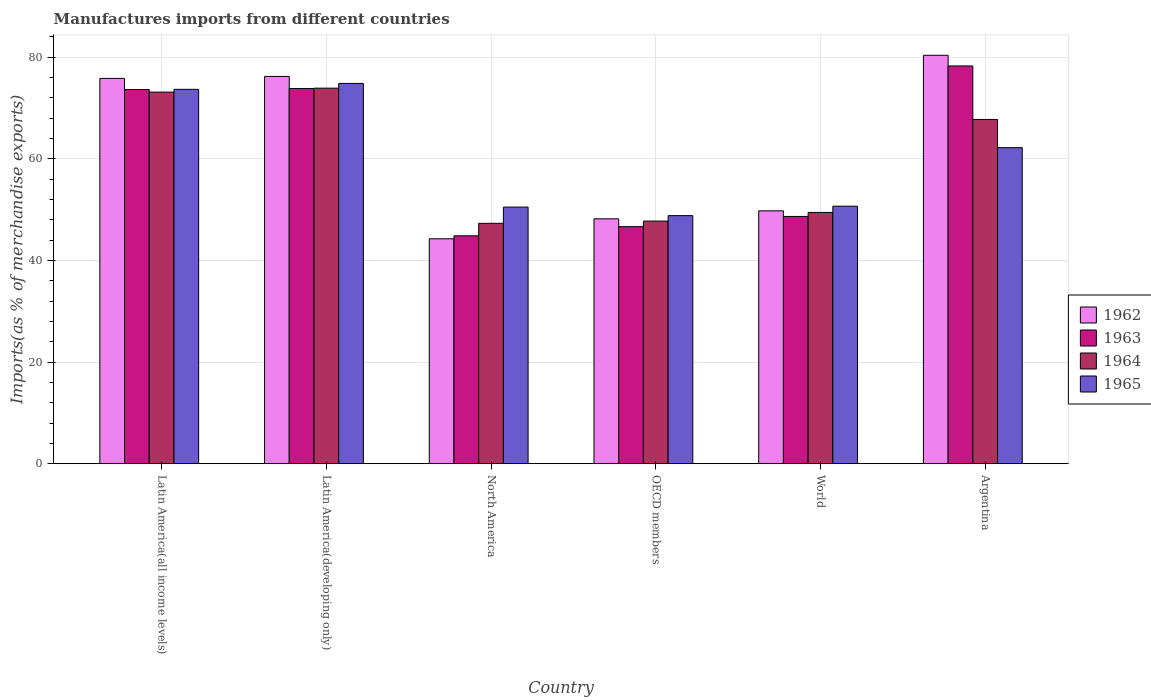How many different coloured bars are there?
Keep it short and to the point. 4. Are the number of bars per tick equal to the number of legend labels?
Make the answer very short. Yes. How many bars are there on the 4th tick from the left?
Give a very brief answer. 4. What is the percentage of imports to different countries in 1963 in OECD members?
Give a very brief answer. 46.65. Across all countries, what is the maximum percentage of imports to different countries in 1963?
Your answer should be very brief. 78.27. Across all countries, what is the minimum percentage of imports to different countries in 1962?
Your response must be concise. 44.26. In which country was the percentage of imports to different countries in 1965 maximum?
Provide a succinct answer. Latin America(developing only). What is the total percentage of imports to different countries in 1963 in the graph?
Your answer should be very brief. 365.9. What is the difference between the percentage of imports to different countries in 1962 in Latin America(all income levels) and that in World?
Ensure brevity in your answer.  26.06. What is the difference between the percentage of imports to different countries in 1965 in North America and the percentage of imports to different countries in 1962 in Latin America(all income levels)?
Offer a terse response. -25.32. What is the average percentage of imports to different countries in 1963 per country?
Provide a succinct answer. 60.98. What is the difference between the percentage of imports to different countries of/in 1965 and percentage of imports to different countries of/in 1963 in North America?
Give a very brief answer. 5.65. What is the ratio of the percentage of imports to different countries in 1963 in OECD members to that in World?
Give a very brief answer. 0.96. What is the difference between the highest and the second highest percentage of imports to different countries in 1965?
Your answer should be compact. -1.16. What is the difference between the highest and the lowest percentage of imports to different countries in 1962?
Offer a terse response. 36.1. Is the sum of the percentage of imports to different countries in 1965 in Argentina and North America greater than the maximum percentage of imports to different countries in 1964 across all countries?
Provide a short and direct response. Yes. What does the 3rd bar from the left in Argentina represents?
Make the answer very short. 1964. Is it the case that in every country, the sum of the percentage of imports to different countries in 1964 and percentage of imports to different countries in 1963 is greater than the percentage of imports to different countries in 1962?
Give a very brief answer. Yes. How many bars are there?
Provide a succinct answer. 24. How many countries are there in the graph?
Offer a terse response. 6. What is the difference between two consecutive major ticks on the Y-axis?
Your answer should be compact. 20. Are the values on the major ticks of Y-axis written in scientific E-notation?
Offer a very short reply. No. Does the graph contain any zero values?
Provide a short and direct response. No. How many legend labels are there?
Your answer should be very brief. 4. How are the legend labels stacked?
Your answer should be very brief. Vertical. What is the title of the graph?
Offer a terse response. Manufactures imports from different countries. What is the label or title of the Y-axis?
Your answer should be compact. Imports(as % of merchandise exports). What is the Imports(as % of merchandise exports) in 1962 in Latin America(all income levels)?
Keep it short and to the point. 75.82. What is the Imports(as % of merchandise exports) in 1963 in Latin America(all income levels)?
Your answer should be compact. 73.64. What is the Imports(as % of merchandise exports) in 1964 in Latin America(all income levels)?
Offer a terse response. 73.13. What is the Imports(as % of merchandise exports) in 1965 in Latin America(all income levels)?
Your response must be concise. 73.67. What is the Imports(as % of merchandise exports) of 1962 in Latin America(developing only)?
Your answer should be very brief. 76.21. What is the Imports(as % of merchandise exports) of 1963 in Latin America(developing only)?
Offer a terse response. 73.84. What is the Imports(as % of merchandise exports) in 1964 in Latin America(developing only)?
Your response must be concise. 73.9. What is the Imports(as % of merchandise exports) in 1965 in Latin America(developing only)?
Your answer should be very brief. 74.83. What is the Imports(as % of merchandise exports) of 1962 in North America?
Your answer should be very brief. 44.26. What is the Imports(as % of merchandise exports) in 1963 in North America?
Ensure brevity in your answer.  44.85. What is the Imports(as % of merchandise exports) in 1964 in North America?
Provide a succinct answer. 47.3. What is the Imports(as % of merchandise exports) of 1965 in North America?
Offer a terse response. 50.5. What is the Imports(as % of merchandise exports) in 1962 in OECD members?
Provide a short and direct response. 48.19. What is the Imports(as % of merchandise exports) of 1963 in OECD members?
Provide a succinct answer. 46.65. What is the Imports(as % of merchandise exports) of 1964 in OECD members?
Your response must be concise. 47.75. What is the Imports(as % of merchandise exports) of 1965 in OECD members?
Provide a short and direct response. 48.82. What is the Imports(as % of merchandise exports) of 1962 in World?
Your answer should be compact. 49.76. What is the Imports(as % of merchandise exports) of 1963 in World?
Provide a succinct answer. 48.66. What is the Imports(as % of merchandise exports) of 1964 in World?
Provide a succinct answer. 49.45. What is the Imports(as % of merchandise exports) of 1965 in World?
Your answer should be very brief. 50.68. What is the Imports(as % of merchandise exports) of 1962 in Argentina?
Offer a very short reply. 80.37. What is the Imports(as % of merchandise exports) of 1963 in Argentina?
Offer a terse response. 78.27. What is the Imports(as % of merchandise exports) in 1964 in Argentina?
Ensure brevity in your answer.  67.75. What is the Imports(as % of merchandise exports) in 1965 in Argentina?
Give a very brief answer. 62.19. Across all countries, what is the maximum Imports(as % of merchandise exports) in 1962?
Ensure brevity in your answer.  80.37. Across all countries, what is the maximum Imports(as % of merchandise exports) in 1963?
Give a very brief answer. 78.27. Across all countries, what is the maximum Imports(as % of merchandise exports) in 1964?
Give a very brief answer. 73.9. Across all countries, what is the maximum Imports(as % of merchandise exports) in 1965?
Keep it short and to the point. 74.83. Across all countries, what is the minimum Imports(as % of merchandise exports) in 1962?
Provide a succinct answer. 44.26. Across all countries, what is the minimum Imports(as % of merchandise exports) of 1963?
Give a very brief answer. 44.85. Across all countries, what is the minimum Imports(as % of merchandise exports) of 1964?
Ensure brevity in your answer.  47.3. Across all countries, what is the minimum Imports(as % of merchandise exports) in 1965?
Provide a short and direct response. 48.82. What is the total Imports(as % of merchandise exports) of 1962 in the graph?
Keep it short and to the point. 374.61. What is the total Imports(as % of merchandise exports) of 1963 in the graph?
Give a very brief answer. 365.9. What is the total Imports(as % of merchandise exports) in 1964 in the graph?
Give a very brief answer. 359.27. What is the total Imports(as % of merchandise exports) of 1965 in the graph?
Your answer should be compact. 360.69. What is the difference between the Imports(as % of merchandise exports) of 1962 in Latin America(all income levels) and that in Latin America(developing only)?
Your answer should be very brief. -0.39. What is the difference between the Imports(as % of merchandise exports) of 1963 in Latin America(all income levels) and that in Latin America(developing only)?
Keep it short and to the point. -0.2. What is the difference between the Imports(as % of merchandise exports) in 1964 in Latin America(all income levels) and that in Latin America(developing only)?
Provide a short and direct response. -0.77. What is the difference between the Imports(as % of merchandise exports) in 1965 in Latin America(all income levels) and that in Latin America(developing only)?
Your answer should be compact. -1.16. What is the difference between the Imports(as % of merchandise exports) in 1962 in Latin America(all income levels) and that in North America?
Provide a succinct answer. 31.56. What is the difference between the Imports(as % of merchandise exports) of 1963 in Latin America(all income levels) and that in North America?
Make the answer very short. 28.79. What is the difference between the Imports(as % of merchandise exports) in 1964 in Latin America(all income levels) and that in North America?
Offer a terse response. 25.82. What is the difference between the Imports(as % of merchandise exports) of 1965 in Latin America(all income levels) and that in North America?
Your response must be concise. 23.17. What is the difference between the Imports(as % of merchandise exports) of 1962 in Latin America(all income levels) and that in OECD members?
Offer a very short reply. 27.63. What is the difference between the Imports(as % of merchandise exports) of 1963 in Latin America(all income levels) and that in OECD members?
Provide a succinct answer. 26.99. What is the difference between the Imports(as % of merchandise exports) of 1964 in Latin America(all income levels) and that in OECD members?
Provide a succinct answer. 25.38. What is the difference between the Imports(as % of merchandise exports) in 1965 in Latin America(all income levels) and that in OECD members?
Make the answer very short. 24.85. What is the difference between the Imports(as % of merchandise exports) of 1962 in Latin America(all income levels) and that in World?
Give a very brief answer. 26.06. What is the difference between the Imports(as % of merchandise exports) of 1963 in Latin America(all income levels) and that in World?
Your response must be concise. 24.98. What is the difference between the Imports(as % of merchandise exports) of 1964 in Latin America(all income levels) and that in World?
Ensure brevity in your answer.  23.68. What is the difference between the Imports(as % of merchandise exports) of 1965 in Latin America(all income levels) and that in World?
Offer a terse response. 22.99. What is the difference between the Imports(as % of merchandise exports) in 1962 in Latin America(all income levels) and that in Argentina?
Your answer should be very brief. -4.55. What is the difference between the Imports(as % of merchandise exports) of 1963 in Latin America(all income levels) and that in Argentina?
Keep it short and to the point. -4.63. What is the difference between the Imports(as % of merchandise exports) in 1964 in Latin America(all income levels) and that in Argentina?
Your answer should be compact. 5.38. What is the difference between the Imports(as % of merchandise exports) in 1965 in Latin America(all income levels) and that in Argentina?
Ensure brevity in your answer.  11.47. What is the difference between the Imports(as % of merchandise exports) in 1962 in Latin America(developing only) and that in North America?
Provide a succinct answer. 31.95. What is the difference between the Imports(as % of merchandise exports) of 1963 in Latin America(developing only) and that in North America?
Provide a succinct answer. 28.99. What is the difference between the Imports(as % of merchandise exports) in 1964 in Latin America(developing only) and that in North America?
Your response must be concise. 26.6. What is the difference between the Imports(as % of merchandise exports) of 1965 in Latin America(developing only) and that in North America?
Offer a very short reply. 24.33. What is the difference between the Imports(as % of merchandise exports) of 1962 in Latin America(developing only) and that in OECD members?
Give a very brief answer. 28.02. What is the difference between the Imports(as % of merchandise exports) in 1963 in Latin America(developing only) and that in OECD members?
Offer a terse response. 27.19. What is the difference between the Imports(as % of merchandise exports) of 1964 in Latin America(developing only) and that in OECD members?
Provide a short and direct response. 26.16. What is the difference between the Imports(as % of merchandise exports) of 1965 in Latin America(developing only) and that in OECD members?
Offer a very short reply. 26.01. What is the difference between the Imports(as % of merchandise exports) in 1962 in Latin America(developing only) and that in World?
Make the answer very short. 26.45. What is the difference between the Imports(as % of merchandise exports) in 1963 in Latin America(developing only) and that in World?
Give a very brief answer. 25.18. What is the difference between the Imports(as % of merchandise exports) of 1964 in Latin America(developing only) and that in World?
Offer a very short reply. 24.45. What is the difference between the Imports(as % of merchandise exports) of 1965 in Latin America(developing only) and that in World?
Your response must be concise. 24.15. What is the difference between the Imports(as % of merchandise exports) of 1962 in Latin America(developing only) and that in Argentina?
Your response must be concise. -4.15. What is the difference between the Imports(as % of merchandise exports) in 1963 in Latin America(developing only) and that in Argentina?
Your response must be concise. -4.43. What is the difference between the Imports(as % of merchandise exports) in 1964 in Latin America(developing only) and that in Argentina?
Keep it short and to the point. 6.16. What is the difference between the Imports(as % of merchandise exports) of 1965 in Latin America(developing only) and that in Argentina?
Provide a succinct answer. 12.64. What is the difference between the Imports(as % of merchandise exports) in 1962 in North America and that in OECD members?
Your answer should be compact. -3.93. What is the difference between the Imports(as % of merchandise exports) in 1963 in North America and that in OECD members?
Your answer should be compact. -1.8. What is the difference between the Imports(as % of merchandise exports) in 1964 in North America and that in OECD members?
Provide a succinct answer. -0.44. What is the difference between the Imports(as % of merchandise exports) of 1965 in North America and that in OECD members?
Your answer should be very brief. 1.68. What is the difference between the Imports(as % of merchandise exports) in 1962 in North America and that in World?
Make the answer very short. -5.5. What is the difference between the Imports(as % of merchandise exports) of 1963 in North America and that in World?
Your response must be concise. -3.81. What is the difference between the Imports(as % of merchandise exports) in 1964 in North America and that in World?
Offer a terse response. -2.14. What is the difference between the Imports(as % of merchandise exports) of 1965 in North America and that in World?
Your answer should be very brief. -0.18. What is the difference between the Imports(as % of merchandise exports) in 1962 in North America and that in Argentina?
Provide a succinct answer. -36.1. What is the difference between the Imports(as % of merchandise exports) in 1963 in North America and that in Argentina?
Make the answer very short. -33.42. What is the difference between the Imports(as % of merchandise exports) in 1964 in North America and that in Argentina?
Your response must be concise. -20.44. What is the difference between the Imports(as % of merchandise exports) in 1965 in North America and that in Argentina?
Your answer should be very brief. -11.69. What is the difference between the Imports(as % of merchandise exports) of 1962 in OECD members and that in World?
Your response must be concise. -1.57. What is the difference between the Imports(as % of merchandise exports) in 1963 in OECD members and that in World?
Make the answer very short. -2.01. What is the difference between the Imports(as % of merchandise exports) of 1964 in OECD members and that in World?
Offer a very short reply. -1.7. What is the difference between the Imports(as % of merchandise exports) in 1965 in OECD members and that in World?
Your answer should be compact. -1.86. What is the difference between the Imports(as % of merchandise exports) of 1962 in OECD members and that in Argentina?
Your answer should be compact. -32.17. What is the difference between the Imports(as % of merchandise exports) in 1963 in OECD members and that in Argentina?
Keep it short and to the point. -31.62. What is the difference between the Imports(as % of merchandise exports) of 1964 in OECD members and that in Argentina?
Ensure brevity in your answer.  -20. What is the difference between the Imports(as % of merchandise exports) in 1965 in OECD members and that in Argentina?
Your response must be concise. -13.38. What is the difference between the Imports(as % of merchandise exports) of 1962 in World and that in Argentina?
Provide a succinct answer. -30.61. What is the difference between the Imports(as % of merchandise exports) in 1963 in World and that in Argentina?
Give a very brief answer. -29.61. What is the difference between the Imports(as % of merchandise exports) in 1964 in World and that in Argentina?
Offer a terse response. -18.3. What is the difference between the Imports(as % of merchandise exports) in 1965 in World and that in Argentina?
Give a very brief answer. -11.52. What is the difference between the Imports(as % of merchandise exports) of 1962 in Latin America(all income levels) and the Imports(as % of merchandise exports) of 1963 in Latin America(developing only)?
Your answer should be compact. 1.98. What is the difference between the Imports(as % of merchandise exports) of 1962 in Latin America(all income levels) and the Imports(as % of merchandise exports) of 1964 in Latin America(developing only)?
Offer a terse response. 1.92. What is the difference between the Imports(as % of merchandise exports) of 1962 in Latin America(all income levels) and the Imports(as % of merchandise exports) of 1965 in Latin America(developing only)?
Offer a very short reply. 0.99. What is the difference between the Imports(as % of merchandise exports) of 1963 in Latin America(all income levels) and the Imports(as % of merchandise exports) of 1964 in Latin America(developing only)?
Offer a very short reply. -0.26. What is the difference between the Imports(as % of merchandise exports) in 1963 in Latin America(all income levels) and the Imports(as % of merchandise exports) in 1965 in Latin America(developing only)?
Offer a terse response. -1.2. What is the difference between the Imports(as % of merchandise exports) in 1964 in Latin America(all income levels) and the Imports(as % of merchandise exports) in 1965 in Latin America(developing only)?
Ensure brevity in your answer.  -1.71. What is the difference between the Imports(as % of merchandise exports) in 1962 in Latin America(all income levels) and the Imports(as % of merchandise exports) in 1963 in North America?
Offer a terse response. 30.97. What is the difference between the Imports(as % of merchandise exports) of 1962 in Latin America(all income levels) and the Imports(as % of merchandise exports) of 1964 in North America?
Your response must be concise. 28.51. What is the difference between the Imports(as % of merchandise exports) in 1962 in Latin America(all income levels) and the Imports(as % of merchandise exports) in 1965 in North America?
Ensure brevity in your answer.  25.32. What is the difference between the Imports(as % of merchandise exports) of 1963 in Latin America(all income levels) and the Imports(as % of merchandise exports) of 1964 in North America?
Offer a terse response. 26.33. What is the difference between the Imports(as % of merchandise exports) in 1963 in Latin America(all income levels) and the Imports(as % of merchandise exports) in 1965 in North America?
Ensure brevity in your answer.  23.13. What is the difference between the Imports(as % of merchandise exports) of 1964 in Latin America(all income levels) and the Imports(as % of merchandise exports) of 1965 in North America?
Give a very brief answer. 22.62. What is the difference between the Imports(as % of merchandise exports) in 1962 in Latin America(all income levels) and the Imports(as % of merchandise exports) in 1963 in OECD members?
Keep it short and to the point. 29.17. What is the difference between the Imports(as % of merchandise exports) of 1962 in Latin America(all income levels) and the Imports(as % of merchandise exports) of 1964 in OECD members?
Offer a very short reply. 28.07. What is the difference between the Imports(as % of merchandise exports) in 1962 in Latin America(all income levels) and the Imports(as % of merchandise exports) in 1965 in OECD members?
Your answer should be very brief. 27. What is the difference between the Imports(as % of merchandise exports) in 1963 in Latin America(all income levels) and the Imports(as % of merchandise exports) in 1964 in OECD members?
Offer a terse response. 25.89. What is the difference between the Imports(as % of merchandise exports) in 1963 in Latin America(all income levels) and the Imports(as % of merchandise exports) in 1965 in OECD members?
Provide a succinct answer. 24.82. What is the difference between the Imports(as % of merchandise exports) in 1964 in Latin America(all income levels) and the Imports(as % of merchandise exports) in 1965 in OECD members?
Offer a very short reply. 24.31. What is the difference between the Imports(as % of merchandise exports) in 1962 in Latin America(all income levels) and the Imports(as % of merchandise exports) in 1963 in World?
Provide a short and direct response. 27.16. What is the difference between the Imports(as % of merchandise exports) in 1962 in Latin America(all income levels) and the Imports(as % of merchandise exports) in 1964 in World?
Your answer should be very brief. 26.37. What is the difference between the Imports(as % of merchandise exports) in 1962 in Latin America(all income levels) and the Imports(as % of merchandise exports) in 1965 in World?
Provide a short and direct response. 25.14. What is the difference between the Imports(as % of merchandise exports) in 1963 in Latin America(all income levels) and the Imports(as % of merchandise exports) in 1964 in World?
Keep it short and to the point. 24.19. What is the difference between the Imports(as % of merchandise exports) in 1963 in Latin America(all income levels) and the Imports(as % of merchandise exports) in 1965 in World?
Provide a short and direct response. 22.96. What is the difference between the Imports(as % of merchandise exports) of 1964 in Latin America(all income levels) and the Imports(as % of merchandise exports) of 1965 in World?
Provide a short and direct response. 22.45. What is the difference between the Imports(as % of merchandise exports) in 1962 in Latin America(all income levels) and the Imports(as % of merchandise exports) in 1963 in Argentina?
Offer a very short reply. -2.45. What is the difference between the Imports(as % of merchandise exports) in 1962 in Latin America(all income levels) and the Imports(as % of merchandise exports) in 1964 in Argentina?
Offer a terse response. 8.07. What is the difference between the Imports(as % of merchandise exports) in 1962 in Latin America(all income levels) and the Imports(as % of merchandise exports) in 1965 in Argentina?
Your response must be concise. 13.62. What is the difference between the Imports(as % of merchandise exports) in 1963 in Latin America(all income levels) and the Imports(as % of merchandise exports) in 1964 in Argentina?
Provide a short and direct response. 5.89. What is the difference between the Imports(as % of merchandise exports) in 1963 in Latin America(all income levels) and the Imports(as % of merchandise exports) in 1965 in Argentina?
Your answer should be very brief. 11.44. What is the difference between the Imports(as % of merchandise exports) of 1964 in Latin America(all income levels) and the Imports(as % of merchandise exports) of 1965 in Argentina?
Ensure brevity in your answer.  10.93. What is the difference between the Imports(as % of merchandise exports) of 1962 in Latin America(developing only) and the Imports(as % of merchandise exports) of 1963 in North America?
Provide a succinct answer. 31.36. What is the difference between the Imports(as % of merchandise exports) of 1962 in Latin America(developing only) and the Imports(as % of merchandise exports) of 1964 in North America?
Your response must be concise. 28.91. What is the difference between the Imports(as % of merchandise exports) in 1962 in Latin America(developing only) and the Imports(as % of merchandise exports) in 1965 in North America?
Your response must be concise. 25.71. What is the difference between the Imports(as % of merchandise exports) of 1963 in Latin America(developing only) and the Imports(as % of merchandise exports) of 1964 in North America?
Ensure brevity in your answer.  26.53. What is the difference between the Imports(as % of merchandise exports) in 1963 in Latin America(developing only) and the Imports(as % of merchandise exports) in 1965 in North America?
Your answer should be very brief. 23.34. What is the difference between the Imports(as % of merchandise exports) of 1964 in Latin America(developing only) and the Imports(as % of merchandise exports) of 1965 in North America?
Keep it short and to the point. 23.4. What is the difference between the Imports(as % of merchandise exports) of 1962 in Latin America(developing only) and the Imports(as % of merchandise exports) of 1963 in OECD members?
Offer a terse response. 29.57. What is the difference between the Imports(as % of merchandise exports) of 1962 in Latin America(developing only) and the Imports(as % of merchandise exports) of 1964 in OECD members?
Make the answer very short. 28.47. What is the difference between the Imports(as % of merchandise exports) of 1962 in Latin America(developing only) and the Imports(as % of merchandise exports) of 1965 in OECD members?
Ensure brevity in your answer.  27.39. What is the difference between the Imports(as % of merchandise exports) in 1963 in Latin America(developing only) and the Imports(as % of merchandise exports) in 1964 in OECD members?
Give a very brief answer. 26.09. What is the difference between the Imports(as % of merchandise exports) in 1963 in Latin America(developing only) and the Imports(as % of merchandise exports) in 1965 in OECD members?
Make the answer very short. 25.02. What is the difference between the Imports(as % of merchandise exports) of 1964 in Latin America(developing only) and the Imports(as % of merchandise exports) of 1965 in OECD members?
Your answer should be very brief. 25.08. What is the difference between the Imports(as % of merchandise exports) of 1962 in Latin America(developing only) and the Imports(as % of merchandise exports) of 1963 in World?
Offer a very short reply. 27.55. What is the difference between the Imports(as % of merchandise exports) in 1962 in Latin America(developing only) and the Imports(as % of merchandise exports) in 1964 in World?
Make the answer very short. 26.76. What is the difference between the Imports(as % of merchandise exports) in 1962 in Latin America(developing only) and the Imports(as % of merchandise exports) in 1965 in World?
Offer a terse response. 25.53. What is the difference between the Imports(as % of merchandise exports) of 1963 in Latin America(developing only) and the Imports(as % of merchandise exports) of 1964 in World?
Offer a very short reply. 24.39. What is the difference between the Imports(as % of merchandise exports) in 1963 in Latin America(developing only) and the Imports(as % of merchandise exports) in 1965 in World?
Ensure brevity in your answer.  23.16. What is the difference between the Imports(as % of merchandise exports) in 1964 in Latin America(developing only) and the Imports(as % of merchandise exports) in 1965 in World?
Give a very brief answer. 23.22. What is the difference between the Imports(as % of merchandise exports) of 1962 in Latin America(developing only) and the Imports(as % of merchandise exports) of 1963 in Argentina?
Offer a very short reply. -2.06. What is the difference between the Imports(as % of merchandise exports) in 1962 in Latin America(developing only) and the Imports(as % of merchandise exports) in 1964 in Argentina?
Offer a very short reply. 8.47. What is the difference between the Imports(as % of merchandise exports) in 1962 in Latin America(developing only) and the Imports(as % of merchandise exports) in 1965 in Argentina?
Your answer should be very brief. 14.02. What is the difference between the Imports(as % of merchandise exports) in 1963 in Latin America(developing only) and the Imports(as % of merchandise exports) in 1964 in Argentina?
Offer a terse response. 6.09. What is the difference between the Imports(as % of merchandise exports) in 1963 in Latin America(developing only) and the Imports(as % of merchandise exports) in 1965 in Argentina?
Offer a terse response. 11.64. What is the difference between the Imports(as % of merchandise exports) in 1964 in Latin America(developing only) and the Imports(as % of merchandise exports) in 1965 in Argentina?
Your answer should be compact. 11.71. What is the difference between the Imports(as % of merchandise exports) in 1962 in North America and the Imports(as % of merchandise exports) in 1963 in OECD members?
Your response must be concise. -2.38. What is the difference between the Imports(as % of merchandise exports) of 1962 in North America and the Imports(as % of merchandise exports) of 1964 in OECD members?
Provide a succinct answer. -3.48. What is the difference between the Imports(as % of merchandise exports) of 1962 in North America and the Imports(as % of merchandise exports) of 1965 in OECD members?
Provide a succinct answer. -4.56. What is the difference between the Imports(as % of merchandise exports) of 1963 in North America and the Imports(as % of merchandise exports) of 1964 in OECD members?
Your answer should be very brief. -2.89. What is the difference between the Imports(as % of merchandise exports) in 1963 in North America and the Imports(as % of merchandise exports) in 1965 in OECD members?
Your response must be concise. -3.97. What is the difference between the Imports(as % of merchandise exports) in 1964 in North America and the Imports(as % of merchandise exports) in 1965 in OECD members?
Provide a succinct answer. -1.52. What is the difference between the Imports(as % of merchandise exports) of 1962 in North America and the Imports(as % of merchandise exports) of 1963 in World?
Keep it short and to the point. -4.4. What is the difference between the Imports(as % of merchandise exports) of 1962 in North America and the Imports(as % of merchandise exports) of 1964 in World?
Your answer should be compact. -5.19. What is the difference between the Imports(as % of merchandise exports) in 1962 in North America and the Imports(as % of merchandise exports) in 1965 in World?
Ensure brevity in your answer.  -6.42. What is the difference between the Imports(as % of merchandise exports) of 1963 in North America and the Imports(as % of merchandise exports) of 1964 in World?
Keep it short and to the point. -4.6. What is the difference between the Imports(as % of merchandise exports) in 1963 in North America and the Imports(as % of merchandise exports) in 1965 in World?
Make the answer very short. -5.83. What is the difference between the Imports(as % of merchandise exports) of 1964 in North America and the Imports(as % of merchandise exports) of 1965 in World?
Your response must be concise. -3.37. What is the difference between the Imports(as % of merchandise exports) of 1962 in North America and the Imports(as % of merchandise exports) of 1963 in Argentina?
Your response must be concise. -34.01. What is the difference between the Imports(as % of merchandise exports) of 1962 in North America and the Imports(as % of merchandise exports) of 1964 in Argentina?
Your answer should be compact. -23.48. What is the difference between the Imports(as % of merchandise exports) of 1962 in North America and the Imports(as % of merchandise exports) of 1965 in Argentina?
Ensure brevity in your answer.  -17.93. What is the difference between the Imports(as % of merchandise exports) of 1963 in North America and the Imports(as % of merchandise exports) of 1964 in Argentina?
Your response must be concise. -22.89. What is the difference between the Imports(as % of merchandise exports) in 1963 in North America and the Imports(as % of merchandise exports) in 1965 in Argentina?
Your response must be concise. -17.34. What is the difference between the Imports(as % of merchandise exports) of 1964 in North America and the Imports(as % of merchandise exports) of 1965 in Argentina?
Your response must be concise. -14.89. What is the difference between the Imports(as % of merchandise exports) in 1962 in OECD members and the Imports(as % of merchandise exports) in 1963 in World?
Make the answer very short. -0.47. What is the difference between the Imports(as % of merchandise exports) of 1962 in OECD members and the Imports(as % of merchandise exports) of 1964 in World?
Offer a terse response. -1.26. What is the difference between the Imports(as % of merchandise exports) in 1962 in OECD members and the Imports(as % of merchandise exports) in 1965 in World?
Your answer should be very brief. -2.49. What is the difference between the Imports(as % of merchandise exports) in 1963 in OECD members and the Imports(as % of merchandise exports) in 1964 in World?
Your answer should be compact. -2.8. What is the difference between the Imports(as % of merchandise exports) in 1963 in OECD members and the Imports(as % of merchandise exports) in 1965 in World?
Your answer should be compact. -4.03. What is the difference between the Imports(as % of merchandise exports) of 1964 in OECD members and the Imports(as % of merchandise exports) of 1965 in World?
Your answer should be very brief. -2.93. What is the difference between the Imports(as % of merchandise exports) in 1962 in OECD members and the Imports(as % of merchandise exports) in 1963 in Argentina?
Your answer should be compact. -30.08. What is the difference between the Imports(as % of merchandise exports) in 1962 in OECD members and the Imports(as % of merchandise exports) in 1964 in Argentina?
Give a very brief answer. -19.55. What is the difference between the Imports(as % of merchandise exports) in 1962 in OECD members and the Imports(as % of merchandise exports) in 1965 in Argentina?
Ensure brevity in your answer.  -14. What is the difference between the Imports(as % of merchandise exports) in 1963 in OECD members and the Imports(as % of merchandise exports) in 1964 in Argentina?
Offer a terse response. -21.1. What is the difference between the Imports(as % of merchandise exports) in 1963 in OECD members and the Imports(as % of merchandise exports) in 1965 in Argentina?
Keep it short and to the point. -15.55. What is the difference between the Imports(as % of merchandise exports) of 1964 in OECD members and the Imports(as % of merchandise exports) of 1965 in Argentina?
Offer a terse response. -14.45. What is the difference between the Imports(as % of merchandise exports) in 1962 in World and the Imports(as % of merchandise exports) in 1963 in Argentina?
Your response must be concise. -28.51. What is the difference between the Imports(as % of merchandise exports) in 1962 in World and the Imports(as % of merchandise exports) in 1964 in Argentina?
Ensure brevity in your answer.  -17.98. What is the difference between the Imports(as % of merchandise exports) of 1962 in World and the Imports(as % of merchandise exports) of 1965 in Argentina?
Ensure brevity in your answer.  -12.43. What is the difference between the Imports(as % of merchandise exports) in 1963 in World and the Imports(as % of merchandise exports) in 1964 in Argentina?
Ensure brevity in your answer.  -19.09. What is the difference between the Imports(as % of merchandise exports) in 1963 in World and the Imports(as % of merchandise exports) in 1965 in Argentina?
Keep it short and to the point. -13.54. What is the difference between the Imports(as % of merchandise exports) in 1964 in World and the Imports(as % of merchandise exports) in 1965 in Argentina?
Give a very brief answer. -12.75. What is the average Imports(as % of merchandise exports) of 1962 per country?
Give a very brief answer. 62.44. What is the average Imports(as % of merchandise exports) in 1963 per country?
Offer a terse response. 60.98. What is the average Imports(as % of merchandise exports) in 1964 per country?
Offer a very short reply. 59.88. What is the average Imports(as % of merchandise exports) in 1965 per country?
Offer a very short reply. 60.12. What is the difference between the Imports(as % of merchandise exports) in 1962 and Imports(as % of merchandise exports) in 1963 in Latin America(all income levels)?
Keep it short and to the point. 2.18. What is the difference between the Imports(as % of merchandise exports) in 1962 and Imports(as % of merchandise exports) in 1964 in Latin America(all income levels)?
Make the answer very short. 2.69. What is the difference between the Imports(as % of merchandise exports) of 1962 and Imports(as % of merchandise exports) of 1965 in Latin America(all income levels)?
Keep it short and to the point. 2.15. What is the difference between the Imports(as % of merchandise exports) of 1963 and Imports(as % of merchandise exports) of 1964 in Latin America(all income levels)?
Your response must be concise. 0.51. What is the difference between the Imports(as % of merchandise exports) of 1963 and Imports(as % of merchandise exports) of 1965 in Latin America(all income levels)?
Give a very brief answer. -0.03. What is the difference between the Imports(as % of merchandise exports) in 1964 and Imports(as % of merchandise exports) in 1965 in Latin America(all income levels)?
Your answer should be very brief. -0.54. What is the difference between the Imports(as % of merchandise exports) of 1962 and Imports(as % of merchandise exports) of 1963 in Latin America(developing only)?
Offer a terse response. 2.37. What is the difference between the Imports(as % of merchandise exports) in 1962 and Imports(as % of merchandise exports) in 1964 in Latin America(developing only)?
Give a very brief answer. 2.31. What is the difference between the Imports(as % of merchandise exports) in 1962 and Imports(as % of merchandise exports) in 1965 in Latin America(developing only)?
Provide a short and direct response. 1.38. What is the difference between the Imports(as % of merchandise exports) of 1963 and Imports(as % of merchandise exports) of 1964 in Latin America(developing only)?
Offer a very short reply. -0.06. What is the difference between the Imports(as % of merchandise exports) in 1963 and Imports(as % of merchandise exports) in 1965 in Latin America(developing only)?
Keep it short and to the point. -0.99. What is the difference between the Imports(as % of merchandise exports) in 1964 and Imports(as % of merchandise exports) in 1965 in Latin America(developing only)?
Your answer should be very brief. -0.93. What is the difference between the Imports(as % of merchandise exports) of 1962 and Imports(as % of merchandise exports) of 1963 in North America?
Provide a succinct answer. -0.59. What is the difference between the Imports(as % of merchandise exports) in 1962 and Imports(as % of merchandise exports) in 1964 in North America?
Offer a very short reply. -3.04. What is the difference between the Imports(as % of merchandise exports) of 1962 and Imports(as % of merchandise exports) of 1965 in North America?
Provide a short and direct response. -6.24. What is the difference between the Imports(as % of merchandise exports) in 1963 and Imports(as % of merchandise exports) in 1964 in North America?
Ensure brevity in your answer.  -2.45. What is the difference between the Imports(as % of merchandise exports) of 1963 and Imports(as % of merchandise exports) of 1965 in North America?
Your answer should be compact. -5.65. What is the difference between the Imports(as % of merchandise exports) of 1964 and Imports(as % of merchandise exports) of 1965 in North America?
Provide a short and direct response. -3.2. What is the difference between the Imports(as % of merchandise exports) in 1962 and Imports(as % of merchandise exports) in 1963 in OECD members?
Offer a very short reply. 1.55. What is the difference between the Imports(as % of merchandise exports) in 1962 and Imports(as % of merchandise exports) in 1964 in OECD members?
Your response must be concise. 0.45. What is the difference between the Imports(as % of merchandise exports) in 1962 and Imports(as % of merchandise exports) in 1965 in OECD members?
Keep it short and to the point. -0.63. What is the difference between the Imports(as % of merchandise exports) of 1963 and Imports(as % of merchandise exports) of 1964 in OECD members?
Keep it short and to the point. -1.1. What is the difference between the Imports(as % of merchandise exports) of 1963 and Imports(as % of merchandise exports) of 1965 in OECD members?
Keep it short and to the point. -2.17. What is the difference between the Imports(as % of merchandise exports) of 1964 and Imports(as % of merchandise exports) of 1965 in OECD members?
Provide a succinct answer. -1.07. What is the difference between the Imports(as % of merchandise exports) in 1962 and Imports(as % of merchandise exports) in 1963 in World?
Offer a very short reply. 1.1. What is the difference between the Imports(as % of merchandise exports) in 1962 and Imports(as % of merchandise exports) in 1964 in World?
Provide a succinct answer. 0.31. What is the difference between the Imports(as % of merchandise exports) of 1962 and Imports(as % of merchandise exports) of 1965 in World?
Make the answer very short. -0.92. What is the difference between the Imports(as % of merchandise exports) of 1963 and Imports(as % of merchandise exports) of 1964 in World?
Your answer should be very brief. -0.79. What is the difference between the Imports(as % of merchandise exports) in 1963 and Imports(as % of merchandise exports) in 1965 in World?
Ensure brevity in your answer.  -2.02. What is the difference between the Imports(as % of merchandise exports) in 1964 and Imports(as % of merchandise exports) in 1965 in World?
Your answer should be very brief. -1.23. What is the difference between the Imports(as % of merchandise exports) of 1962 and Imports(as % of merchandise exports) of 1963 in Argentina?
Offer a terse response. 2.1. What is the difference between the Imports(as % of merchandise exports) of 1962 and Imports(as % of merchandise exports) of 1964 in Argentina?
Provide a short and direct response. 12.62. What is the difference between the Imports(as % of merchandise exports) in 1962 and Imports(as % of merchandise exports) in 1965 in Argentina?
Your answer should be very brief. 18.17. What is the difference between the Imports(as % of merchandise exports) of 1963 and Imports(as % of merchandise exports) of 1964 in Argentina?
Your response must be concise. 10.52. What is the difference between the Imports(as % of merchandise exports) of 1963 and Imports(as % of merchandise exports) of 1965 in Argentina?
Your answer should be compact. 16.08. What is the difference between the Imports(as % of merchandise exports) of 1964 and Imports(as % of merchandise exports) of 1965 in Argentina?
Your answer should be compact. 5.55. What is the ratio of the Imports(as % of merchandise exports) in 1962 in Latin America(all income levels) to that in Latin America(developing only)?
Your response must be concise. 0.99. What is the ratio of the Imports(as % of merchandise exports) in 1963 in Latin America(all income levels) to that in Latin America(developing only)?
Your response must be concise. 1. What is the ratio of the Imports(as % of merchandise exports) of 1964 in Latin America(all income levels) to that in Latin America(developing only)?
Offer a very short reply. 0.99. What is the ratio of the Imports(as % of merchandise exports) of 1965 in Latin America(all income levels) to that in Latin America(developing only)?
Provide a short and direct response. 0.98. What is the ratio of the Imports(as % of merchandise exports) in 1962 in Latin America(all income levels) to that in North America?
Offer a very short reply. 1.71. What is the ratio of the Imports(as % of merchandise exports) of 1963 in Latin America(all income levels) to that in North America?
Offer a terse response. 1.64. What is the ratio of the Imports(as % of merchandise exports) of 1964 in Latin America(all income levels) to that in North America?
Make the answer very short. 1.55. What is the ratio of the Imports(as % of merchandise exports) of 1965 in Latin America(all income levels) to that in North America?
Provide a succinct answer. 1.46. What is the ratio of the Imports(as % of merchandise exports) of 1962 in Latin America(all income levels) to that in OECD members?
Give a very brief answer. 1.57. What is the ratio of the Imports(as % of merchandise exports) in 1963 in Latin America(all income levels) to that in OECD members?
Your answer should be compact. 1.58. What is the ratio of the Imports(as % of merchandise exports) in 1964 in Latin America(all income levels) to that in OECD members?
Keep it short and to the point. 1.53. What is the ratio of the Imports(as % of merchandise exports) of 1965 in Latin America(all income levels) to that in OECD members?
Make the answer very short. 1.51. What is the ratio of the Imports(as % of merchandise exports) in 1962 in Latin America(all income levels) to that in World?
Offer a terse response. 1.52. What is the ratio of the Imports(as % of merchandise exports) of 1963 in Latin America(all income levels) to that in World?
Offer a very short reply. 1.51. What is the ratio of the Imports(as % of merchandise exports) of 1964 in Latin America(all income levels) to that in World?
Your answer should be very brief. 1.48. What is the ratio of the Imports(as % of merchandise exports) in 1965 in Latin America(all income levels) to that in World?
Ensure brevity in your answer.  1.45. What is the ratio of the Imports(as % of merchandise exports) in 1962 in Latin America(all income levels) to that in Argentina?
Your answer should be compact. 0.94. What is the ratio of the Imports(as % of merchandise exports) in 1963 in Latin America(all income levels) to that in Argentina?
Keep it short and to the point. 0.94. What is the ratio of the Imports(as % of merchandise exports) in 1964 in Latin America(all income levels) to that in Argentina?
Keep it short and to the point. 1.08. What is the ratio of the Imports(as % of merchandise exports) in 1965 in Latin America(all income levels) to that in Argentina?
Offer a terse response. 1.18. What is the ratio of the Imports(as % of merchandise exports) in 1962 in Latin America(developing only) to that in North America?
Offer a terse response. 1.72. What is the ratio of the Imports(as % of merchandise exports) in 1963 in Latin America(developing only) to that in North America?
Offer a very short reply. 1.65. What is the ratio of the Imports(as % of merchandise exports) of 1964 in Latin America(developing only) to that in North America?
Give a very brief answer. 1.56. What is the ratio of the Imports(as % of merchandise exports) in 1965 in Latin America(developing only) to that in North America?
Offer a terse response. 1.48. What is the ratio of the Imports(as % of merchandise exports) in 1962 in Latin America(developing only) to that in OECD members?
Your answer should be very brief. 1.58. What is the ratio of the Imports(as % of merchandise exports) of 1963 in Latin America(developing only) to that in OECD members?
Ensure brevity in your answer.  1.58. What is the ratio of the Imports(as % of merchandise exports) in 1964 in Latin America(developing only) to that in OECD members?
Your response must be concise. 1.55. What is the ratio of the Imports(as % of merchandise exports) in 1965 in Latin America(developing only) to that in OECD members?
Offer a very short reply. 1.53. What is the ratio of the Imports(as % of merchandise exports) of 1962 in Latin America(developing only) to that in World?
Provide a succinct answer. 1.53. What is the ratio of the Imports(as % of merchandise exports) of 1963 in Latin America(developing only) to that in World?
Ensure brevity in your answer.  1.52. What is the ratio of the Imports(as % of merchandise exports) in 1964 in Latin America(developing only) to that in World?
Offer a terse response. 1.49. What is the ratio of the Imports(as % of merchandise exports) of 1965 in Latin America(developing only) to that in World?
Provide a short and direct response. 1.48. What is the ratio of the Imports(as % of merchandise exports) in 1962 in Latin America(developing only) to that in Argentina?
Your answer should be very brief. 0.95. What is the ratio of the Imports(as % of merchandise exports) of 1963 in Latin America(developing only) to that in Argentina?
Keep it short and to the point. 0.94. What is the ratio of the Imports(as % of merchandise exports) in 1964 in Latin America(developing only) to that in Argentina?
Your answer should be very brief. 1.09. What is the ratio of the Imports(as % of merchandise exports) in 1965 in Latin America(developing only) to that in Argentina?
Offer a terse response. 1.2. What is the ratio of the Imports(as % of merchandise exports) of 1962 in North America to that in OECD members?
Offer a terse response. 0.92. What is the ratio of the Imports(as % of merchandise exports) in 1963 in North America to that in OECD members?
Provide a succinct answer. 0.96. What is the ratio of the Imports(as % of merchandise exports) of 1964 in North America to that in OECD members?
Provide a succinct answer. 0.99. What is the ratio of the Imports(as % of merchandise exports) of 1965 in North America to that in OECD members?
Provide a succinct answer. 1.03. What is the ratio of the Imports(as % of merchandise exports) in 1962 in North America to that in World?
Your answer should be very brief. 0.89. What is the ratio of the Imports(as % of merchandise exports) of 1963 in North America to that in World?
Provide a short and direct response. 0.92. What is the ratio of the Imports(as % of merchandise exports) in 1964 in North America to that in World?
Your response must be concise. 0.96. What is the ratio of the Imports(as % of merchandise exports) in 1965 in North America to that in World?
Your answer should be compact. 1. What is the ratio of the Imports(as % of merchandise exports) of 1962 in North America to that in Argentina?
Provide a succinct answer. 0.55. What is the ratio of the Imports(as % of merchandise exports) in 1963 in North America to that in Argentina?
Keep it short and to the point. 0.57. What is the ratio of the Imports(as % of merchandise exports) of 1964 in North America to that in Argentina?
Your answer should be compact. 0.7. What is the ratio of the Imports(as % of merchandise exports) in 1965 in North America to that in Argentina?
Offer a terse response. 0.81. What is the ratio of the Imports(as % of merchandise exports) in 1962 in OECD members to that in World?
Keep it short and to the point. 0.97. What is the ratio of the Imports(as % of merchandise exports) of 1963 in OECD members to that in World?
Your answer should be compact. 0.96. What is the ratio of the Imports(as % of merchandise exports) in 1964 in OECD members to that in World?
Provide a short and direct response. 0.97. What is the ratio of the Imports(as % of merchandise exports) in 1965 in OECD members to that in World?
Your response must be concise. 0.96. What is the ratio of the Imports(as % of merchandise exports) of 1962 in OECD members to that in Argentina?
Your answer should be very brief. 0.6. What is the ratio of the Imports(as % of merchandise exports) of 1963 in OECD members to that in Argentina?
Offer a terse response. 0.6. What is the ratio of the Imports(as % of merchandise exports) of 1964 in OECD members to that in Argentina?
Your answer should be compact. 0.7. What is the ratio of the Imports(as % of merchandise exports) in 1965 in OECD members to that in Argentina?
Ensure brevity in your answer.  0.78. What is the ratio of the Imports(as % of merchandise exports) of 1962 in World to that in Argentina?
Your response must be concise. 0.62. What is the ratio of the Imports(as % of merchandise exports) of 1963 in World to that in Argentina?
Give a very brief answer. 0.62. What is the ratio of the Imports(as % of merchandise exports) of 1964 in World to that in Argentina?
Provide a succinct answer. 0.73. What is the ratio of the Imports(as % of merchandise exports) in 1965 in World to that in Argentina?
Your answer should be very brief. 0.81. What is the difference between the highest and the second highest Imports(as % of merchandise exports) in 1962?
Your answer should be very brief. 4.15. What is the difference between the highest and the second highest Imports(as % of merchandise exports) of 1963?
Provide a short and direct response. 4.43. What is the difference between the highest and the second highest Imports(as % of merchandise exports) in 1964?
Your response must be concise. 0.77. What is the difference between the highest and the second highest Imports(as % of merchandise exports) of 1965?
Provide a succinct answer. 1.16. What is the difference between the highest and the lowest Imports(as % of merchandise exports) in 1962?
Provide a short and direct response. 36.1. What is the difference between the highest and the lowest Imports(as % of merchandise exports) in 1963?
Your answer should be compact. 33.42. What is the difference between the highest and the lowest Imports(as % of merchandise exports) in 1964?
Ensure brevity in your answer.  26.6. What is the difference between the highest and the lowest Imports(as % of merchandise exports) in 1965?
Provide a succinct answer. 26.01. 